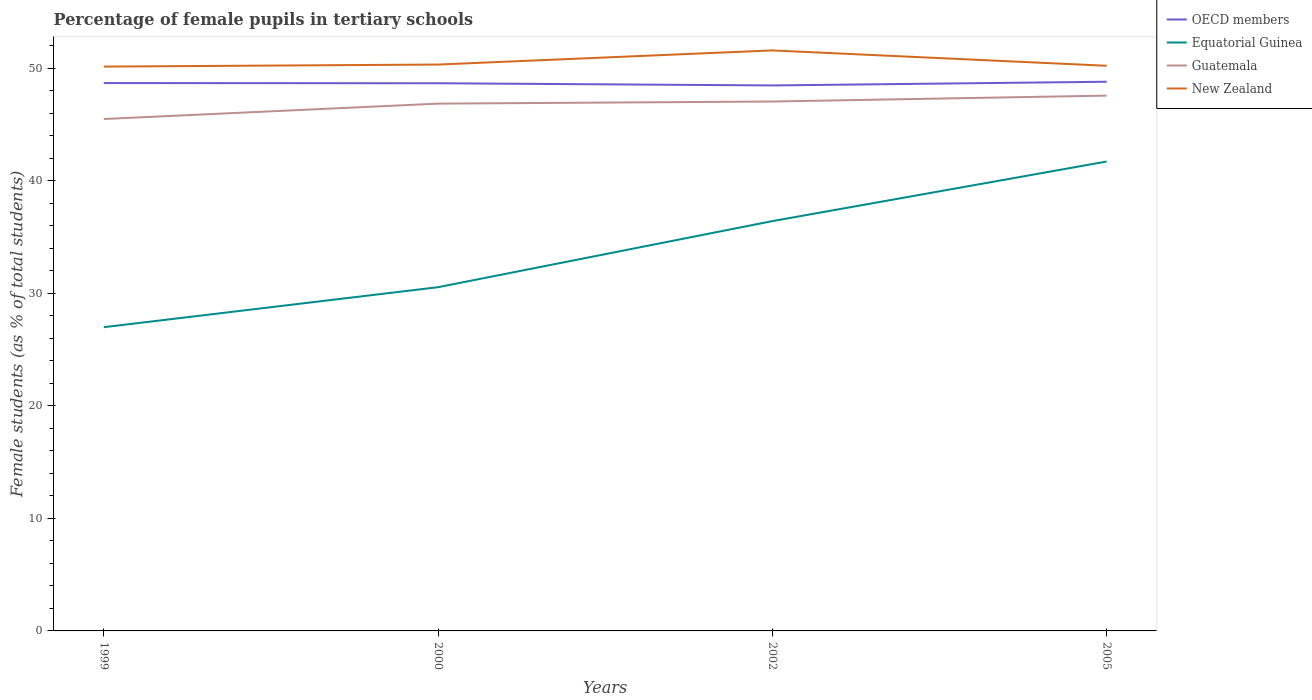How many different coloured lines are there?
Your response must be concise. 4. Does the line corresponding to OECD members intersect with the line corresponding to Guatemala?
Give a very brief answer. No. Across all years, what is the maximum percentage of female pupils in tertiary schools in OECD members?
Your answer should be compact. 48.47. In which year was the percentage of female pupils in tertiary schools in OECD members maximum?
Your response must be concise. 2002. What is the total percentage of female pupils in tertiary schools in Guatemala in the graph?
Offer a very short reply. -0.52. What is the difference between the highest and the second highest percentage of female pupils in tertiary schools in Guatemala?
Keep it short and to the point. 2.08. What is the difference between the highest and the lowest percentage of female pupils in tertiary schools in Equatorial Guinea?
Keep it short and to the point. 2. How many lines are there?
Provide a short and direct response. 4. What is the difference between two consecutive major ticks on the Y-axis?
Give a very brief answer. 10. Does the graph contain any zero values?
Make the answer very short. No. Where does the legend appear in the graph?
Keep it short and to the point. Top right. How many legend labels are there?
Your answer should be very brief. 4. What is the title of the graph?
Provide a succinct answer. Percentage of female pupils in tertiary schools. Does "Curacao" appear as one of the legend labels in the graph?
Ensure brevity in your answer.  No. What is the label or title of the X-axis?
Your response must be concise. Years. What is the label or title of the Y-axis?
Keep it short and to the point. Female students (as % of total students). What is the Female students (as % of total students) of OECD members in 1999?
Offer a very short reply. 48.68. What is the Female students (as % of total students) of Equatorial Guinea in 1999?
Make the answer very short. 26.99. What is the Female students (as % of total students) in Guatemala in 1999?
Ensure brevity in your answer.  45.49. What is the Female students (as % of total students) of New Zealand in 1999?
Give a very brief answer. 50.14. What is the Female students (as % of total students) in OECD members in 2000?
Your response must be concise. 48.66. What is the Female students (as % of total students) in Equatorial Guinea in 2000?
Your response must be concise. 30.54. What is the Female students (as % of total students) in Guatemala in 2000?
Ensure brevity in your answer.  46.85. What is the Female students (as % of total students) in New Zealand in 2000?
Provide a succinct answer. 50.32. What is the Female students (as % of total students) in OECD members in 2002?
Make the answer very short. 48.47. What is the Female students (as % of total students) in Equatorial Guinea in 2002?
Offer a very short reply. 36.41. What is the Female students (as % of total students) in Guatemala in 2002?
Offer a terse response. 47.04. What is the Female students (as % of total students) in New Zealand in 2002?
Your answer should be compact. 51.58. What is the Female students (as % of total students) of OECD members in 2005?
Your answer should be very brief. 48.8. What is the Female students (as % of total students) of Equatorial Guinea in 2005?
Make the answer very short. 41.71. What is the Female students (as % of total students) of Guatemala in 2005?
Give a very brief answer. 47.57. What is the Female students (as % of total students) of New Zealand in 2005?
Offer a terse response. 50.22. Across all years, what is the maximum Female students (as % of total students) in OECD members?
Provide a short and direct response. 48.8. Across all years, what is the maximum Female students (as % of total students) in Equatorial Guinea?
Your answer should be very brief. 41.71. Across all years, what is the maximum Female students (as % of total students) of Guatemala?
Provide a short and direct response. 47.57. Across all years, what is the maximum Female students (as % of total students) of New Zealand?
Your answer should be very brief. 51.58. Across all years, what is the minimum Female students (as % of total students) of OECD members?
Your answer should be compact. 48.47. Across all years, what is the minimum Female students (as % of total students) in Equatorial Guinea?
Offer a very short reply. 26.99. Across all years, what is the minimum Female students (as % of total students) in Guatemala?
Give a very brief answer. 45.49. Across all years, what is the minimum Female students (as % of total students) in New Zealand?
Offer a very short reply. 50.14. What is the total Female students (as % of total students) of OECD members in the graph?
Provide a succinct answer. 194.61. What is the total Female students (as % of total students) of Equatorial Guinea in the graph?
Keep it short and to the point. 135.66. What is the total Female students (as % of total students) of Guatemala in the graph?
Keep it short and to the point. 186.94. What is the total Female students (as % of total students) in New Zealand in the graph?
Offer a very short reply. 202.27. What is the difference between the Female students (as % of total students) in OECD members in 1999 and that in 2000?
Provide a short and direct response. 0.02. What is the difference between the Female students (as % of total students) in Equatorial Guinea in 1999 and that in 2000?
Ensure brevity in your answer.  -3.55. What is the difference between the Female students (as % of total students) in Guatemala in 1999 and that in 2000?
Offer a terse response. -1.37. What is the difference between the Female students (as % of total students) in New Zealand in 1999 and that in 2000?
Your answer should be compact. -0.18. What is the difference between the Female students (as % of total students) in OECD members in 1999 and that in 2002?
Keep it short and to the point. 0.21. What is the difference between the Female students (as % of total students) of Equatorial Guinea in 1999 and that in 2002?
Offer a terse response. -9.42. What is the difference between the Female students (as % of total students) of Guatemala in 1999 and that in 2002?
Give a very brief answer. -1.55. What is the difference between the Female students (as % of total students) of New Zealand in 1999 and that in 2002?
Your response must be concise. -1.44. What is the difference between the Female students (as % of total students) in OECD members in 1999 and that in 2005?
Give a very brief answer. -0.12. What is the difference between the Female students (as % of total students) in Equatorial Guinea in 1999 and that in 2005?
Offer a very short reply. -14.72. What is the difference between the Female students (as % of total students) of Guatemala in 1999 and that in 2005?
Your answer should be very brief. -2.08. What is the difference between the Female students (as % of total students) in New Zealand in 1999 and that in 2005?
Ensure brevity in your answer.  -0.07. What is the difference between the Female students (as % of total students) in OECD members in 2000 and that in 2002?
Give a very brief answer. 0.19. What is the difference between the Female students (as % of total students) in Equatorial Guinea in 2000 and that in 2002?
Give a very brief answer. -5.87. What is the difference between the Female students (as % of total students) of Guatemala in 2000 and that in 2002?
Your response must be concise. -0.19. What is the difference between the Female students (as % of total students) in New Zealand in 2000 and that in 2002?
Ensure brevity in your answer.  -1.26. What is the difference between the Female students (as % of total students) in OECD members in 2000 and that in 2005?
Your answer should be very brief. -0.13. What is the difference between the Female students (as % of total students) of Equatorial Guinea in 2000 and that in 2005?
Your answer should be compact. -11.17. What is the difference between the Female students (as % of total students) in Guatemala in 2000 and that in 2005?
Provide a succinct answer. -0.71. What is the difference between the Female students (as % of total students) of New Zealand in 2000 and that in 2005?
Keep it short and to the point. 0.11. What is the difference between the Female students (as % of total students) in OECD members in 2002 and that in 2005?
Keep it short and to the point. -0.33. What is the difference between the Female students (as % of total students) in Equatorial Guinea in 2002 and that in 2005?
Offer a very short reply. -5.29. What is the difference between the Female students (as % of total students) of Guatemala in 2002 and that in 2005?
Your answer should be compact. -0.52. What is the difference between the Female students (as % of total students) of New Zealand in 2002 and that in 2005?
Provide a succinct answer. 1.37. What is the difference between the Female students (as % of total students) in OECD members in 1999 and the Female students (as % of total students) in Equatorial Guinea in 2000?
Offer a terse response. 18.14. What is the difference between the Female students (as % of total students) of OECD members in 1999 and the Female students (as % of total students) of Guatemala in 2000?
Offer a very short reply. 1.83. What is the difference between the Female students (as % of total students) of OECD members in 1999 and the Female students (as % of total students) of New Zealand in 2000?
Provide a succinct answer. -1.64. What is the difference between the Female students (as % of total students) in Equatorial Guinea in 1999 and the Female students (as % of total students) in Guatemala in 2000?
Your answer should be very brief. -19.86. What is the difference between the Female students (as % of total students) in Equatorial Guinea in 1999 and the Female students (as % of total students) in New Zealand in 2000?
Offer a very short reply. -23.34. What is the difference between the Female students (as % of total students) in Guatemala in 1999 and the Female students (as % of total students) in New Zealand in 2000?
Make the answer very short. -4.84. What is the difference between the Female students (as % of total students) of OECD members in 1999 and the Female students (as % of total students) of Equatorial Guinea in 2002?
Ensure brevity in your answer.  12.27. What is the difference between the Female students (as % of total students) in OECD members in 1999 and the Female students (as % of total students) in Guatemala in 2002?
Give a very brief answer. 1.64. What is the difference between the Female students (as % of total students) in OECD members in 1999 and the Female students (as % of total students) in New Zealand in 2002?
Your response must be concise. -2.9. What is the difference between the Female students (as % of total students) of Equatorial Guinea in 1999 and the Female students (as % of total students) of Guatemala in 2002?
Your answer should be compact. -20.05. What is the difference between the Female students (as % of total students) in Equatorial Guinea in 1999 and the Female students (as % of total students) in New Zealand in 2002?
Your answer should be very brief. -24.59. What is the difference between the Female students (as % of total students) of Guatemala in 1999 and the Female students (as % of total students) of New Zealand in 2002?
Provide a succinct answer. -6.09. What is the difference between the Female students (as % of total students) of OECD members in 1999 and the Female students (as % of total students) of Equatorial Guinea in 2005?
Keep it short and to the point. 6.97. What is the difference between the Female students (as % of total students) in OECD members in 1999 and the Female students (as % of total students) in Guatemala in 2005?
Ensure brevity in your answer.  1.11. What is the difference between the Female students (as % of total students) of OECD members in 1999 and the Female students (as % of total students) of New Zealand in 2005?
Offer a terse response. -1.54. What is the difference between the Female students (as % of total students) in Equatorial Guinea in 1999 and the Female students (as % of total students) in Guatemala in 2005?
Make the answer very short. -20.58. What is the difference between the Female students (as % of total students) of Equatorial Guinea in 1999 and the Female students (as % of total students) of New Zealand in 2005?
Your response must be concise. -23.23. What is the difference between the Female students (as % of total students) of Guatemala in 1999 and the Female students (as % of total students) of New Zealand in 2005?
Your answer should be very brief. -4.73. What is the difference between the Female students (as % of total students) of OECD members in 2000 and the Female students (as % of total students) of Equatorial Guinea in 2002?
Keep it short and to the point. 12.25. What is the difference between the Female students (as % of total students) of OECD members in 2000 and the Female students (as % of total students) of Guatemala in 2002?
Your response must be concise. 1.62. What is the difference between the Female students (as % of total students) in OECD members in 2000 and the Female students (as % of total students) in New Zealand in 2002?
Make the answer very short. -2.92. What is the difference between the Female students (as % of total students) of Equatorial Guinea in 2000 and the Female students (as % of total students) of Guatemala in 2002?
Provide a succinct answer. -16.5. What is the difference between the Female students (as % of total students) in Equatorial Guinea in 2000 and the Female students (as % of total students) in New Zealand in 2002?
Offer a terse response. -21.04. What is the difference between the Female students (as % of total students) in Guatemala in 2000 and the Female students (as % of total students) in New Zealand in 2002?
Offer a terse response. -4.73. What is the difference between the Female students (as % of total students) in OECD members in 2000 and the Female students (as % of total students) in Equatorial Guinea in 2005?
Keep it short and to the point. 6.95. What is the difference between the Female students (as % of total students) of OECD members in 2000 and the Female students (as % of total students) of Guatemala in 2005?
Your answer should be very brief. 1.1. What is the difference between the Female students (as % of total students) of OECD members in 2000 and the Female students (as % of total students) of New Zealand in 2005?
Give a very brief answer. -1.55. What is the difference between the Female students (as % of total students) in Equatorial Guinea in 2000 and the Female students (as % of total students) in Guatemala in 2005?
Keep it short and to the point. -17.02. What is the difference between the Female students (as % of total students) in Equatorial Guinea in 2000 and the Female students (as % of total students) in New Zealand in 2005?
Your answer should be very brief. -19.67. What is the difference between the Female students (as % of total students) of Guatemala in 2000 and the Female students (as % of total students) of New Zealand in 2005?
Provide a succinct answer. -3.36. What is the difference between the Female students (as % of total students) of OECD members in 2002 and the Female students (as % of total students) of Equatorial Guinea in 2005?
Keep it short and to the point. 6.76. What is the difference between the Female students (as % of total students) of OECD members in 2002 and the Female students (as % of total students) of Guatemala in 2005?
Provide a succinct answer. 0.9. What is the difference between the Female students (as % of total students) of OECD members in 2002 and the Female students (as % of total students) of New Zealand in 2005?
Offer a terse response. -1.75. What is the difference between the Female students (as % of total students) of Equatorial Guinea in 2002 and the Female students (as % of total students) of Guatemala in 2005?
Your response must be concise. -11.15. What is the difference between the Female students (as % of total students) in Equatorial Guinea in 2002 and the Female students (as % of total students) in New Zealand in 2005?
Offer a very short reply. -13.8. What is the difference between the Female students (as % of total students) of Guatemala in 2002 and the Female students (as % of total students) of New Zealand in 2005?
Provide a short and direct response. -3.18. What is the average Female students (as % of total students) of OECD members per year?
Provide a succinct answer. 48.65. What is the average Female students (as % of total students) in Equatorial Guinea per year?
Your answer should be very brief. 33.91. What is the average Female students (as % of total students) in Guatemala per year?
Your response must be concise. 46.74. What is the average Female students (as % of total students) of New Zealand per year?
Offer a very short reply. 50.57. In the year 1999, what is the difference between the Female students (as % of total students) of OECD members and Female students (as % of total students) of Equatorial Guinea?
Your answer should be compact. 21.69. In the year 1999, what is the difference between the Female students (as % of total students) of OECD members and Female students (as % of total students) of Guatemala?
Provide a short and direct response. 3.19. In the year 1999, what is the difference between the Female students (as % of total students) of OECD members and Female students (as % of total students) of New Zealand?
Your answer should be very brief. -1.46. In the year 1999, what is the difference between the Female students (as % of total students) of Equatorial Guinea and Female students (as % of total students) of Guatemala?
Offer a very short reply. -18.5. In the year 1999, what is the difference between the Female students (as % of total students) in Equatorial Guinea and Female students (as % of total students) in New Zealand?
Provide a succinct answer. -23.15. In the year 1999, what is the difference between the Female students (as % of total students) of Guatemala and Female students (as % of total students) of New Zealand?
Your response must be concise. -4.66. In the year 2000, what is the difference between the Female students (as % of total students) in OECD members and Female students (as % of total students) in Equatorial Guinea?
Provide a succinct answer. 18.12. In the year 2000, what is the difference between the Female students (as % of total students) of OECD members and Female students (as % of total students) of Guatemala?
Ensure brevity in your answer.  1.81. In the year 2000, what is the difference between the Female students (as % of total students) in OECD members and Female students (as % of total students) in New Zealand?
Provide a short and direct response. -1.66. In the year 2000, what is the difference between the Female students (as % of total students) in Equatorial Guinea and Female students (as % of total students) in Guatemala?
Ensure brevity in your answer.  -16.31. In the year 2000, what is the difference between the Female students (as % of total students) of Equatorial Guinea and Female students (as % of total students) of New Zealand?
Provide a succinct answer. -19.78. In the year 2000, what is the difference between the Female students (as % of total students) in Guatemala and Female students (as % of total students) in New Zealand?
Give a very brief answer. -3.47. In the year 2002, what is the difference between the Female students (as % of total students) of OECD members and Female students (as % of total students) of Equatorial Guinea?
Your answer should be very brief. 12.06. In the year 2002, what is the difference between the Female students (as % of total students) of OECD members and Female students (as % of total students) of Guatemala?
Your answer should be compact. 1.43. In the year 2002, what is the difference between the Female students (as % of total students) in OECD members and Female students (as % of total students) in New Zealand?
Ensure brevity in your answer.  -3.11. In the year 2002, what is the difference between the Female students (as % of total students) of Equatorial Guinea and Female students (as % of total students) of Guatemala?
Give a very brief answer. -10.63. In the year 2002, what is the difference between the Female students (as % of total students) in Equatorial Guinea and Female students (as % of total students) in New Zealand?
Your answer should be compact. -15.17. In the year 2002, what is the difference between the Female students (as % of total students) of Guatemala and Female students (as % of total students) of New Zealand?
Provide a succinct answer. -4.54. In the year 2005, what is the difference between the Female students (as % of total students) of OECD members and Female students (as % of total students) of Equatorial Guinea?
Give a very brief answer. 7.09. In the year 2005, what is the difference between the Female students (as % of total students) in OECD members and Female students (as % of total students) in Guatemala?
Ensure brevity in your answer.  1.23. In the year 2005, what is the difference between the Female students (as % of total students) in OECD members and Female students (as % of total students) in New Zealand?
Provide a short and direct response. -1.42. In the year 2005, what is the difference between the Female students (as % of total students) in Equatorial Guinea and Female students (as % of total students) in Guatemala?
Make the answer very short. -5.86. In the year 2005, what is the difference between the Female students (as % of total students) of Equatorial Guinea and Female students (as % of total students) of New Zealand?
Offer a very short reply. -8.51. In the year 2005, what is the difference between the Female students (as % of total students) of Guatemala and Female students (as % of total students) of New Zealand?
Your answer should be compact. -2.65. What is the ratio of the Female students (as % of total students) of Equatorial Guinea in 1999 to that in 2000?
Provide a short and direct response. 0.88. What is the ratio of the Female students (as % of total students) in Guatemala in 1999 to that in 2000?
Keep it short and to the point. 0.97. What is the ratio of the Female students (as % of total students) in New Zealand in 1999 to that in 2000?
Offer a very short reply. 1. What is the ratio of the Female students (as % of total students) of OECD members in 1999 to that in 2002?
Provide a succinct answer. 1. What is the ratio of the Female students (as % of total students) of Equatorial Guinea in 1999 to that in 2002?
Provide a short and direct response. 0.74. What is the ratio of the Female students (as % of total students) in New Zealand in 1999 to that in 2002?
Your answer should be compact. 0.97. What is the ratio of the Female students (as % of total students) in Equatorial Guinea in 1999 to that in 2005?
Offer a very short reply. 0.65. What is the ratio of the Female students (as % of total students) of Guatemala in 1999 to that in 2005?
Keep it short and to the point. 0.96. What is the ratio of the Female students (as % of total students) in New Zealand in 1999 to that in 2005?
Provide a short and direct response. 1. What is the ratio of the Female students (as % of total students) in Equatorial Guinea in 2000 to that in 2002?
Keep it short and to the point. 0.84. What is the ratio of the Female students (as % of total students) of New Zealand in 2000 to that in 2002?
Your answer should be very brief. 0.98. What is the ratio of the Female students (as % of total students) of Equatorial Guinea in 2000 to that in 2005?
Make the answer very short. 0.73. What is the ratio of the Female students (as % of total students) in Guatemala in 2000 to that in 2005?
Keep it short and to the point. 0.98. What is the ratio of the Female students (as % of total students) in OECD members in 2002 to that in 2005?
Keep it short and to the point. 0.99. What is the ratio of the Female students (as % of total students) of Equatorial Guinea in 2002 to that in 2005?
Your answer should be compact. 0.87. What is the ratio of the Female students (as % of total students) in New Zealand in 2002 to that in 2005?
Give a very brief answer. 1.03. What is the difference between the highest and the second highest Female students (as % of total students) in OECD members?
Make the answer very short. 0.12. What is the difference between the highest and the second highest Female students (as % of total students) in Equatorial Guinea?
Provide a succinct answer. 5.29. What is the difference between the highest and the second highest Female students (as % of total students) in Guatemala?
Give a very brief answer. 0.52. What is the difference between the highest and the second highest Female students (as % of total students) in New Zealand?
Your answer should be very brief. 1.26. What is the difference between the highest and the lowest Female students (as % of total students) of OECD members?
Your response must be concise. 0.33. What is the difference between the highest and the lowest Female students (as % of total students) in Equatorial Guinea?
Make the answer very short. 14.72. What is the difference between the highest and the lowest Female students (as % of total students) of Guatemala?
Provide a short and direct response. 2.08. What is the difference between the highest and the lowest Female students (as % of total students) of New Zealand?
Offer a very short reply. 1.44. 